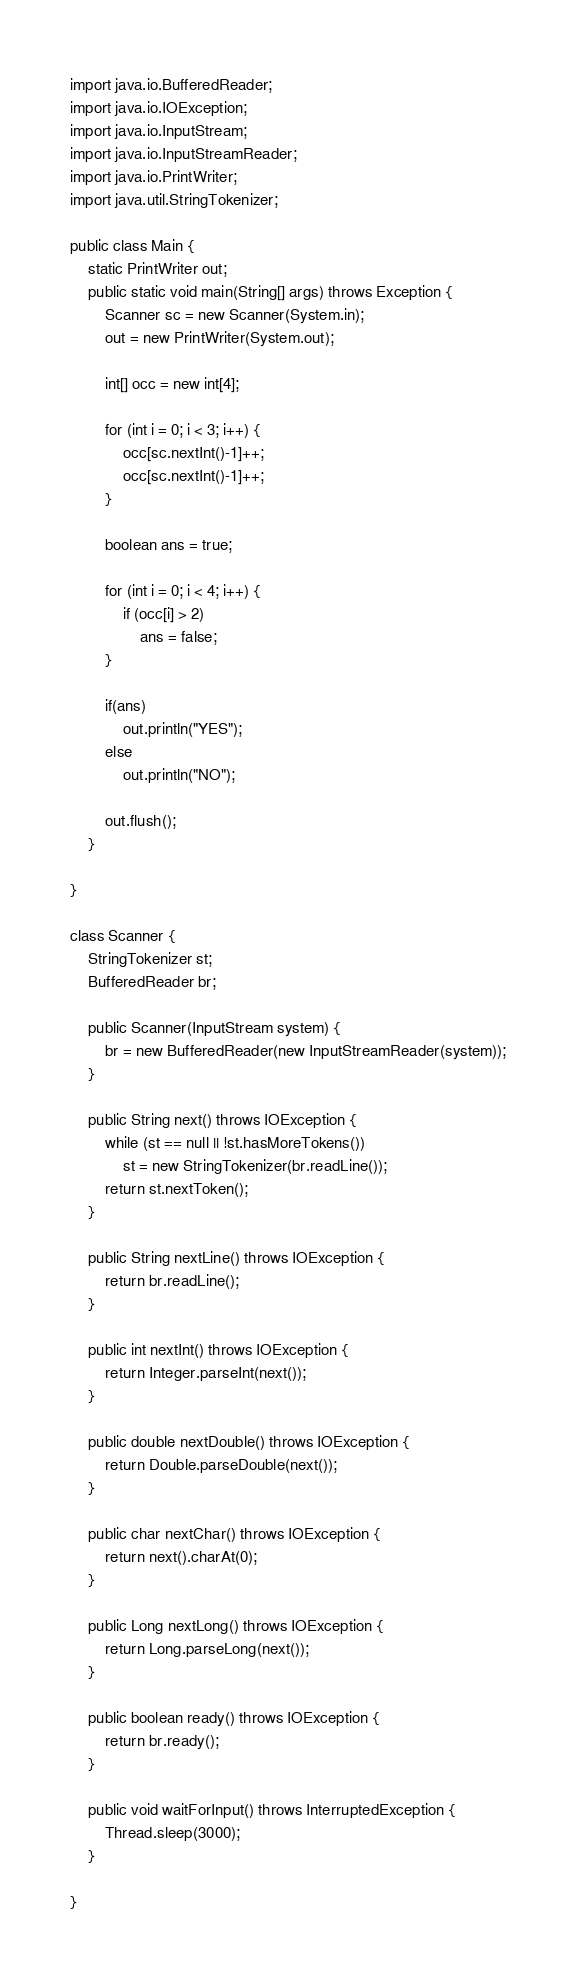<code> <loc_0><loc_0><loc_500><loc_500><_Java_>import java.io.BufferedReader;
import java.io.IOException;
import java.io.InputStream;
import java.io.InputStreamReader;
import java.io.PrintWriter;
import java.util.StringTokenizer;

public class Main {
	static PrintWriter out;
	public static void main(String[] args) throws Exception {
		Scanner sc = new Scanner(System.in);
		out = new PrintWriter(System.out);
		
		int[] occ = new int[4];
	
		for (int i = 0; i < 3; i++) {
			occ[sc.nextInt()-1]++;
			occ[sc.nextInt()-1]++;
		}
		
		boolean ans = true;
		
		for (int i = 0; i < 4; i++) {
			if (occ[i] > 2)
				ans = false;
		}
		
		if(ans)
			out.println("YES");
		else
			out.println("NO");
		
		out.flush();
	}

}
	
class Scanner {
	StringTokenizer st;
	BufferedReader br;

	public Scanner(InputStream system) {
		br = new BufferedReader(new InputStreamReader(system));
	}

	public String next() throws IOException {
		while (st == null || !st.hasMoreTokens())
			st = new StringTokenizer(br.readLine());
		return st.nextToken();
	}

	public String nextLine() throws IOException {
		return br.readLine();
	}

	public int nextInt() throws IOException {
		return Integer.parseInt(next());
	}

	public double nextDouble() throws IOException {
		return Double.parseDouble(next());
	}

	public char nextChar() throws IOException {
		return next().charAt(0);
	}

	public Long nextLong() throws IOException {
		return Long.parseLong(next());
	}

	public boolean ready() throws IOException {
		return br.ready();
	}

	public void waitForInput() throws InterruptedException {
		Thread.sleep(3000);
	}

}
</code> 